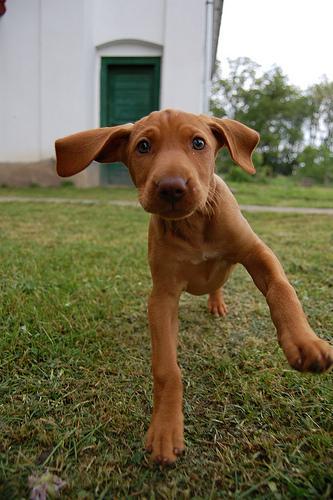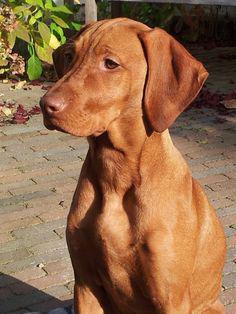The first image is the image on the left, the second image is the image on the right. Analyze the images presented: Is the assertion "Each image shows one dog wearing a collar, and no image shows a dog in an action pose." valid? Answer yes or no. No. The first image is the image on the left, the second image is the image on the right. Considering the images on both sides, is "The dog in the left image is wearing a collar." valid? Answer yes or no. No. 